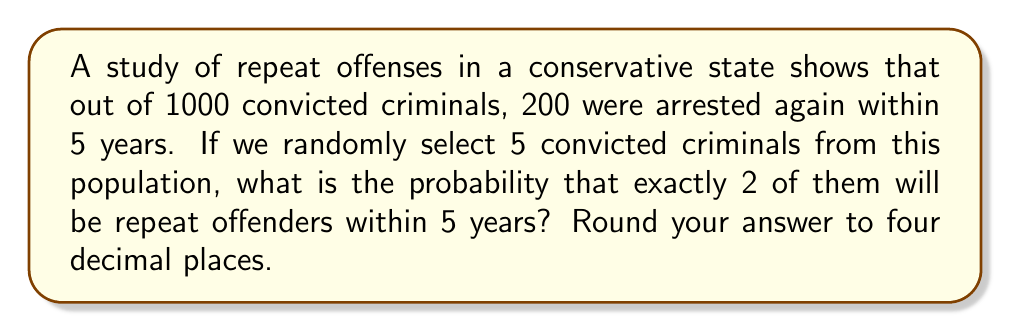Could you help me with this problem? To solve this problem, we'll use the binomial probability formula:

$$ P(X=k) = \binom{n}{k} p^k (1-p)^{n-k} $$

Where:
$n$ = number of trials (5 selected criminals)
$k$ = number of successes (2 repeat offenders)
$p$ = probability of success on each trial (probability of being a repeat offender)

Step 1: Calculate $p$
$p = \frac{200}{1000} = 0.2$

Step 2: Calculate $\binom{n}{k}$
$\binom{5}{2} = \frac{5!}{2!(5-2)!} = \frac{5 \cdot 4}{2 \cdot 1} = 10$

Step 3: Apply the binomial probability formula
$$ P(X=2) = \binom{5}{2} (0.2)^2 (1-0.2)^{5-2} $$
$$ = 10 \cdot (0.2)^2 \cdot (0.8)^3 $$
$$ = 10 \cdot 0.04 \cdot 0.512 $$
$$ = 0.2048 $$

Step 4: Round to four decimal places
$0.2048$ rounded to four decimal places is $0.2048$.
Answer: $0.2048$ 